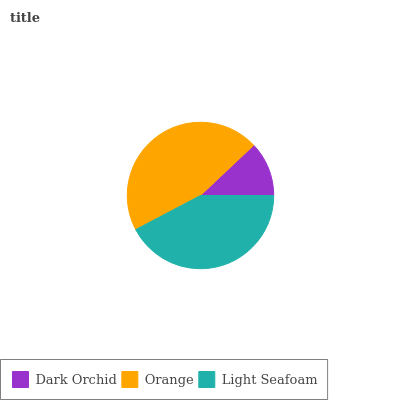Is Dark Orchid the minimum?
Answer yes or no. Yes. Is Orange the maximum?
Answer yes or no. Yes. Is Light Seafoam the minimum?
Answer yes or no. No. Is Light Seafoam the maximum?
Answer yes or no. No. Is Orange greater than Light Seafoam?
Answer yes or no. Yes. Is Light Seafoam less than Orange?
Answer yes or no. Yes. Is Light Seafoam greater than Orange?
Answer yes or no. No. Is Orange less than Light Seafoam?
Answer yes or no. No. Is Light Seafoam the high median?
Answer yes or no. Yes. Is Light Seafoam the low median?
Answer yes or no. Yes. Is Dark Orchid the high median?
Answer yes or no. No. Is Dark Orchid the low median?
Answer yes or no. No. 